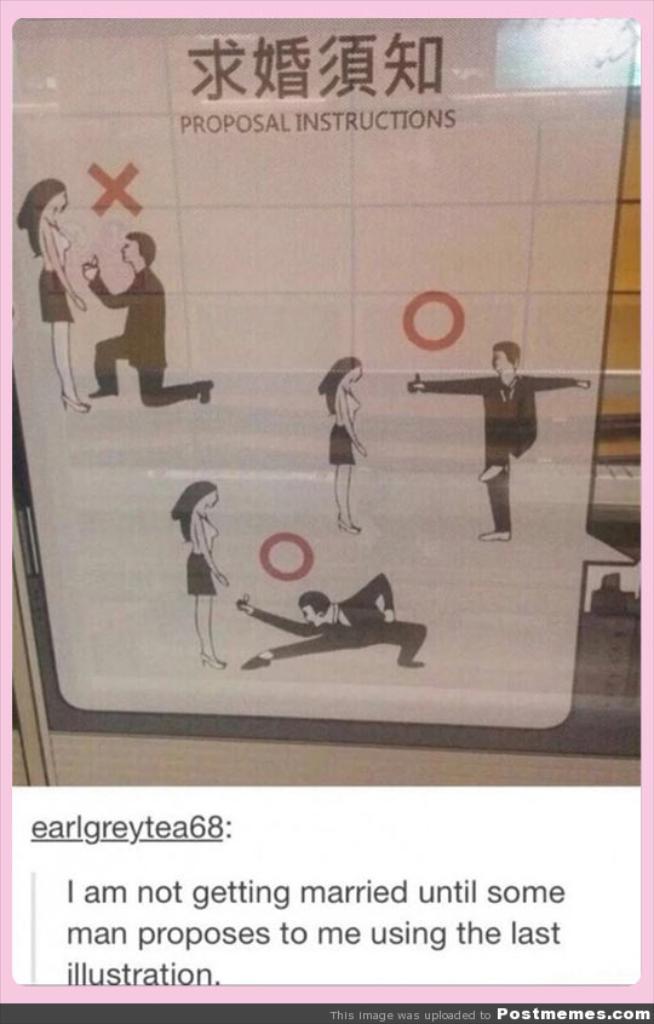<image>
Summarize the visual content of the image. Proposal instructions on a wall that shows a man proposing to a woman. 